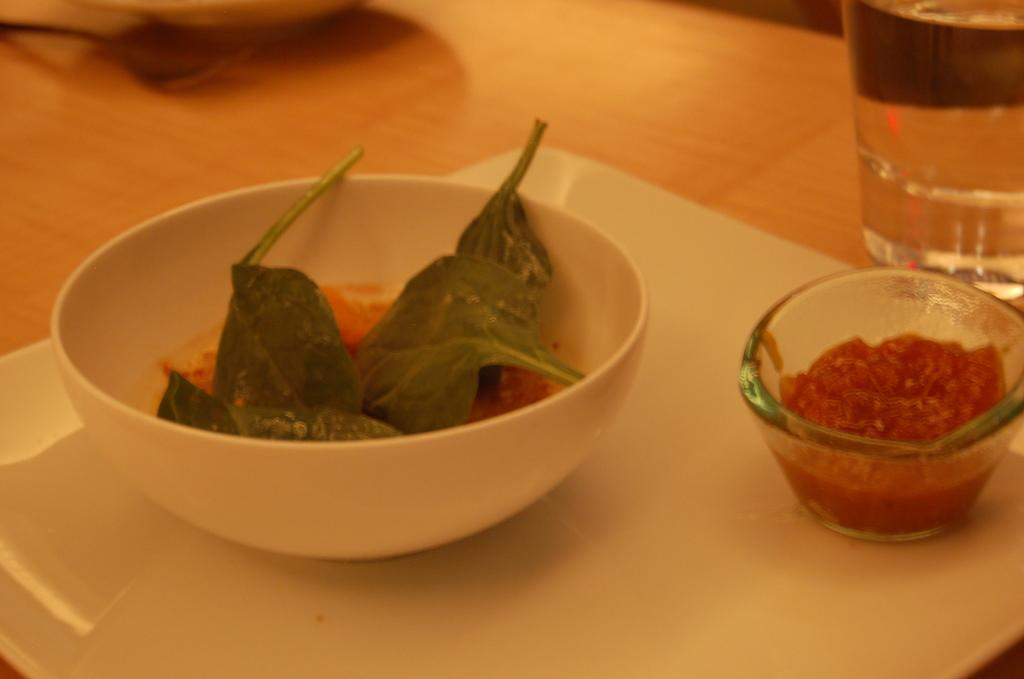What is the main object in the foreground of the image? There is a platter in the foreground of the image. What is on the platter? There is a bowl with leafs and a bowl with red color paste on the platter. Can you describe the background of the image? There is a glass in the background of the image. Where is the glass located? The glass is on a table. What type of education is being taught in the image? There is no indication of any educational activity in the image. Is there a battle taking place in the image? There is no battle or any sign of conflict in the image. 